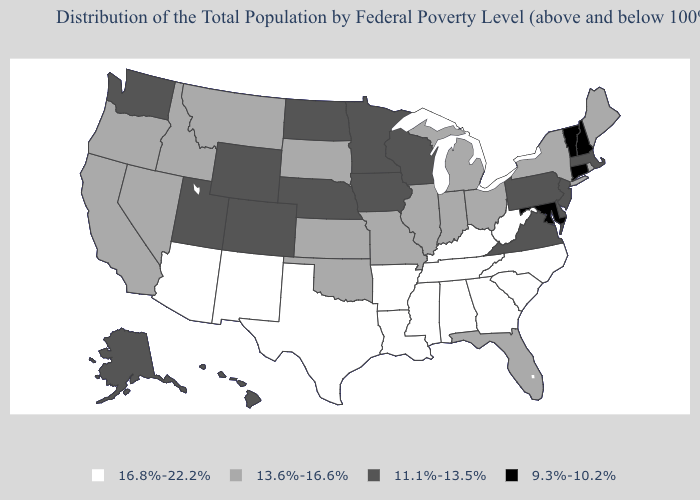What is the value of Michigan?
Answer briefly. 13.6%-16.6%. Name the states that have a value in the range 9.3%-10.2%?
Short answer required. Connecticut, Maryland, New Hampshire, Vermont. Name the states that have a value in the range 13.6%-16.6%?
Give a very brief answer. California, Florida, Idaho, Illinois, Indiana, Kansas, Maine, Michigan, Missouri, Montana, Nevada, New York, Ohio, Oklahoma, Oregon, Rhode Island, South Dakota. Name the states that have a value in the range 16.8%-22.2%?
Concise answer only. Alabama, Arizona, Arkansas, Georgia, Kentucky, Louisiana, Mississippi, New Mexico, North Carolina, South Carolina, Tennessee, Texas, West Virginia. Among the states that border Nebraska , which have the highest value?
Quick response, please. Kansas, Missouri, South Dakota. Does Tennessee have a higher value than Arizona?
Give a very brief answer. No. Does the first symbol in the legend represent the smallest category?
Answer briefly. No. Does Georgia have a higher value than New Mexico?
Give a very brief answer. No. Which states have the lowest value in the South?
Quick response, please. Maryland. Among the states that border Wyoming , does Idaho have the highest value?
Be succinct. Yes. What is the lowest value in the Northeast?
Keep it brief. 9.3%-10.2%. Is the legend a continuous bar?
Quick response, please. No. What is the value of Kentucky?
Quick response, please. 16.8%-22.2%. Name the states that have a value in the range 9.3%-10.2%?
Keep it brief. Connecticut, Maryland, New Hampshire, Vermont. 